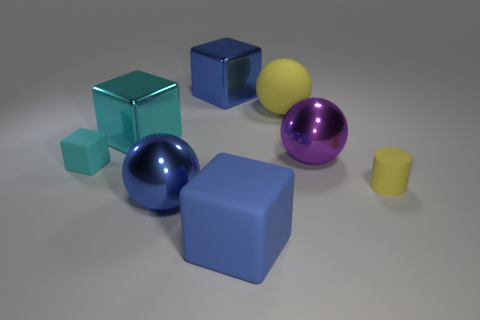Add 2 spheres. How many objects exist? 10 Subtract all cylinders. How many objects are left? 7 Add 7 cyan things. How many cyan things exist? 9 Subtract 0 purple cubes. How many objects are left? 8 Subtract all red matte balls. Subtract all large metal spheres. How many objects are left? 6 Add 8 big cyan metal things. How many big cyan metal things are left? 9 